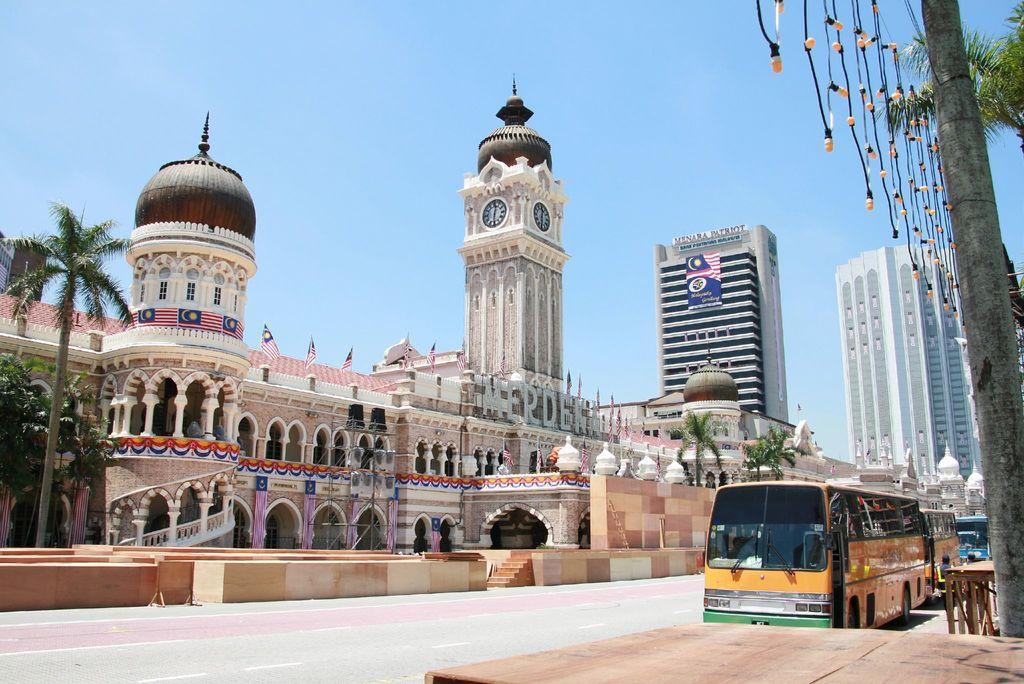Please provide a concise description of this image. In this picture there is a clock tower in the center of the image and there are buildings on the right side of the image and there are trees on the right and left side of the image, there are buses on the right side of the image, it seems to be the road side view. 